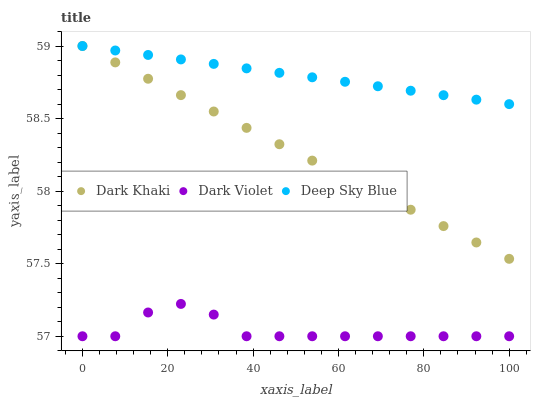Does Dark Violet have the minimum area under the curve?
Answer yes or no. Yes. Does Deep Sky Blue have the maximum area under the curve?
Answer yes or no. Yes. Does Deep Sky Blue have the minimum area under the curve?
Answer yes or no. No. Does Dark Violet have the maximum area under the curve?
Answer yes or no. No. Is Dark Khaki the smoothest?
Answer yes or no. Yes. Is Dark Violet the roughest?
Answer yes or no. Yes. Is Deep Sky Blue the smoothest?
Answer yes or no. No. Is Deep Sky Blue the roughest?
Answer yes or no. No. Does Dark Violet have the lowest value?
Answer yes or no. Yes. Does Deep Sky Blue have the lowest value?
Answer yes or no. No. Does Deep Sky Blue have the highest value?
Answer yes or no. Yes. Does Dark Violet have the highest value?
Answer yes or no. No. Is Dark Violet less than Deep Sky Blue?
Answer yes or no. Yes. Is Dark Khaki greater than Dark Violet?
Answer yes or no. Yes. Does Dark Khaki intersect Deep Sky Blue?
Answer yes or no. Yes. Is Dark Khaki less than Deep Sky Blue?
Answer yes or no. No. Is Dark Khaki greater than Deep Sky Blue?
Answer yes or no. No. Does Dark Violet intersect Deep Sky Blue?
Answer yes or no. No. 